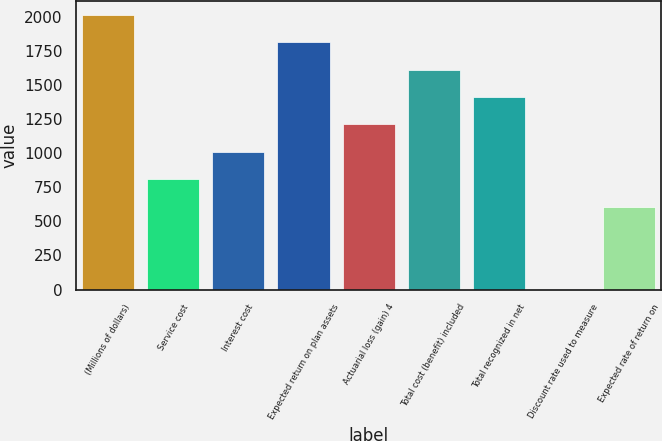<chart> <loc_0><loc_0><loc_500><loc_500><bar_chart><fcel>(Millions of dollars)<fcel>Service cost<fcel>Interest cost<fcel>Expected return on plan assets<fcel>Actuarial loss (gain) 4<fcel>Total cost (benefit) included<fcel>Total recognized in net<fcel>Discount rate used to measure<fcel>Expected rate of return on<nl><fcel>2017<fcel>808.18<fcel>1009.65<fcel>1815.53<fcel>1211.12<fcel>1614.06<fcel>1412.59<fcel>2.3<fcel>606.71<nl></chart> 